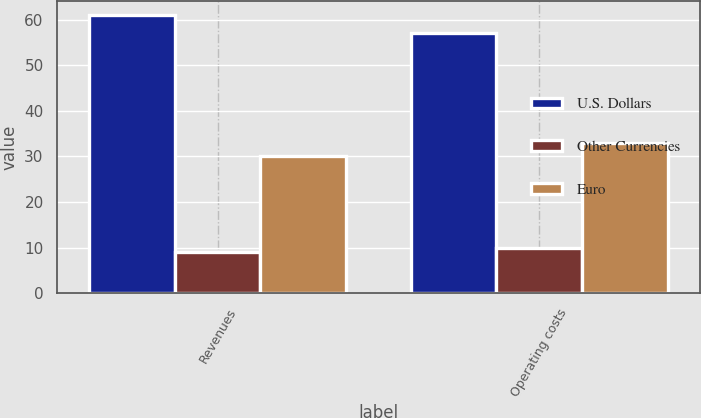Convert chart. <chart><loc_0><loc_0><loc_500><loc_500><stacked_bar_chart><ecel><fcel>Revenues<fcel>Operating costs<nl><fcel>U.S. Dollars<fcel>61<fcel>57<nl><fcel>Other Currencies<fcel>9<fcel>10<nl><fcel>Euro<fcel>30<fcel>33<nl></chart> 